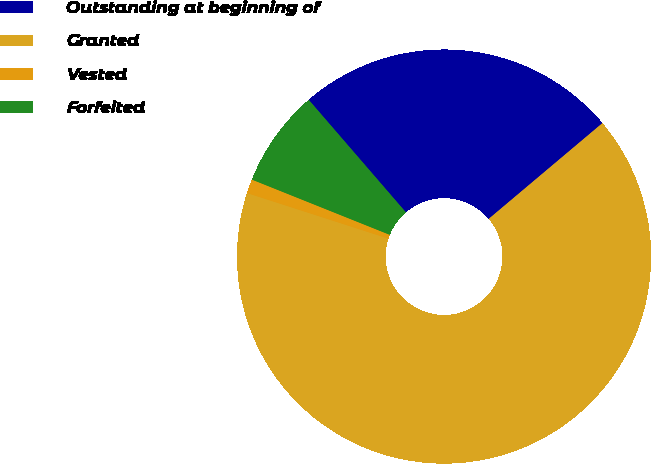<chart> <loc_0><loc_0><loc_500><loc_500><pie_chart><fcel>Outstanding at beginning of<fcel>Granted<fcel>Vested<fcel>Forfeited<nl><fcel>25.2%<fcel>66.11%<fcel>1.1%<fcel>7.6%<nl></chart> 